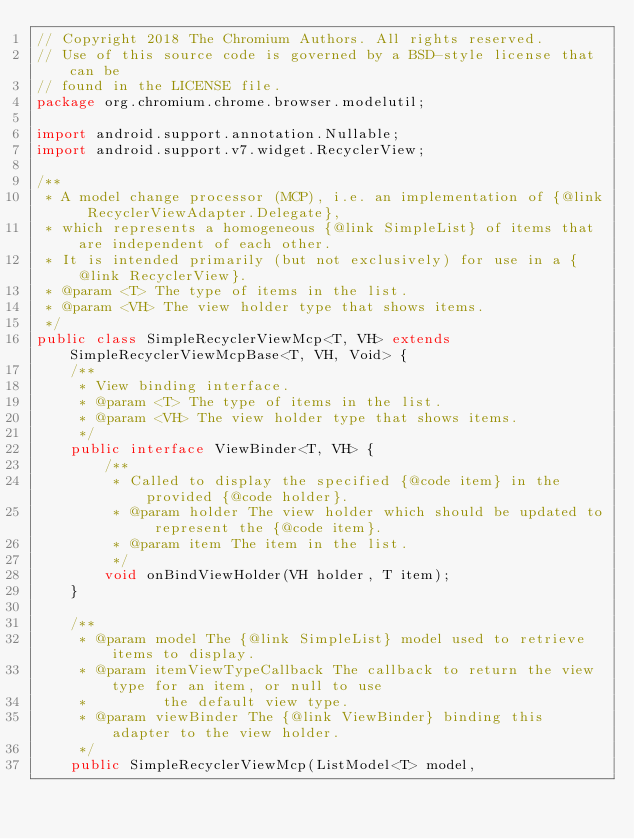<code> <loc_0><loc_0><loc_500><loc_500><_Java_>// Copyright 2018 The Chromium Authors. All rights reserved.
// Use of this source code is governed by a BSD-style license that can be
// found in the LICENSE file.
package org.chromium.chrome.browser.modelutil;

import android.support.annotation.Nullable;
import android.support.v7.widget.RecyclerView;

/**
 * A model change processor (MCP), i.e. an implementation of {@link RecyclerViewAdapter.Delegate},
 * which represents a homogeneous {@link SimpleList} of items that are independent of each other.
 * It is intended primarily (but not exclusively) for use in a {@link RecyclerView}.
 * @param <T> The type of items in the list.
 * @param <VH> The view holder type that shows items.
 */
public class SimpleRecyclerViewMcp<T, VH> extends SimpleRecyclerViewMcpBase<T, VH, Void> {
    /**
     * View binding interface.
     * @param <T> The type of items in the list.
     * @param <VH> The view holder type that shows items.
     */
    public interface ViewBinder<T, VH> {
        /**
         * Called to display the specified {@code item} in the provided {@code holder}.
         * @param holder The view holder which should be updated to represent the {@code item}.
         * @param item The item in the list.
         */
        void onBindViewHolder(VH holder, T item);
    }

    /**
     * @param model The {@link SimpleList} model used to retrieve items to display.
     * @param itemViewTypeCallback The callback to return the view type for an item, or null to use
     *         the default view type.
     * @param viewBinder The {@link ViewBinder} binding this adapter to the view holder.
     */
    public SimpleRecyclerViewMcp(ListModel<T> model,</code> 